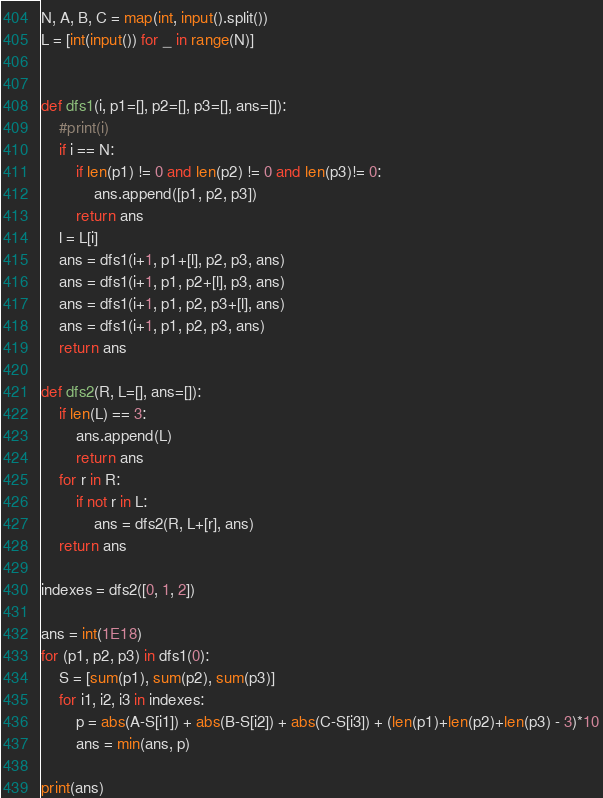<code> <loc_0><loc_0><loc_500><loc_500><_Python_>N, A, B, C = map(int, input().split())
L = [int(input()) for _ in range(N)]


def dfs1(i, p1=[], p2=[], p3=[], ans=[]):
    #print(i)
    if i == N:
        if len(p1) != 0 and len(p2) != 0 and len(p3)!= 0:
            ans.append([p1, p2, p3])
        return ans
    l = L[i]
    ans = dfs1(i+1, p1+[l], p2, p3, ans)
    ans = dfs1(i+1, p1, p2+[l], p3, ans)
    ans = dfs1(i+1, p1, p2, p3+[l], ans)
    ans = dfs1(i+1, p1, p2, p3, ans)
    return ans

def dfs2(R, L=[], ans=[]):
    if len(L) == 3:
        ans.append(L)
        return ans
    for r in R:
        if not r in L:
            ans = dfs2(R, L+[r], ans)
    return ans

indexes = dfs2([0, 1, 2])

ans = int(1E18)
for (p1, p2, p3) in dfs1(0):
    S = [sum(p1), sum(p2), sum(p3)]
    for i1, i2, i3 in indexes:
        p = abs(A-S[i1]) + abs(B-S[i2]) + abs(C-S[i3]) + (len(p1)+len(p2)+len(p3) - 3)*10
        ans = min(ans, p)

print(ans)</code> 